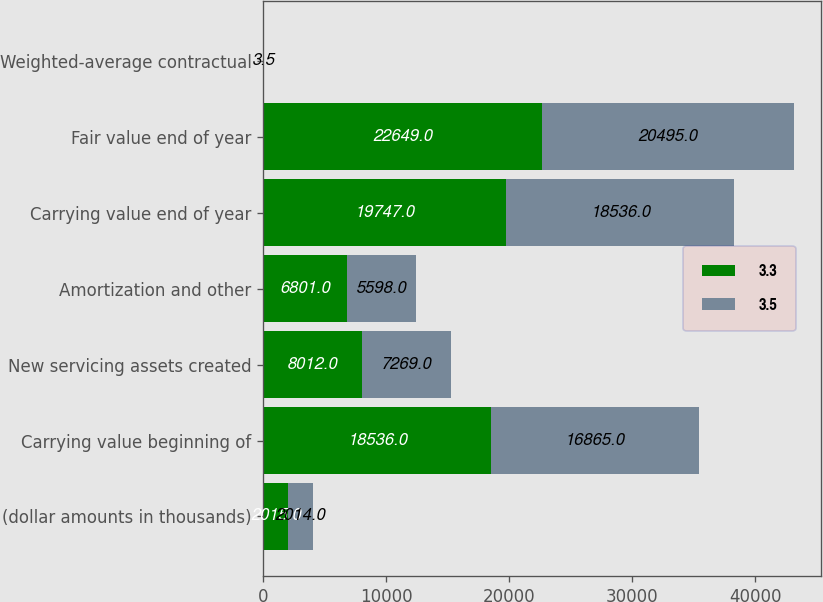Convert chart. <chart><loc_0><loc_0><loc_500><loc_500><stacked_bar_chart><ecel><fcel>(dollar amounts in thousands)<fcel>Carrying value beginning of<fcel>New servicing assets created<fcel>Amortization and other<fcel>Carrying value end of year<fcel>Fair value end of year<fcel>Weighted-average contractual<nl><fcel>3.3<fcel>2015<fcel>18536<fcel>8012<fcel>6801<fcel>19747<fcel>22649<fcel>3.3<nl><fcel>3.5<fcel>2014<fcel>16865<fcel>7269<fcel>5598<fcel>18536<fcel>20495<fcel>3.5<nl></chart> 